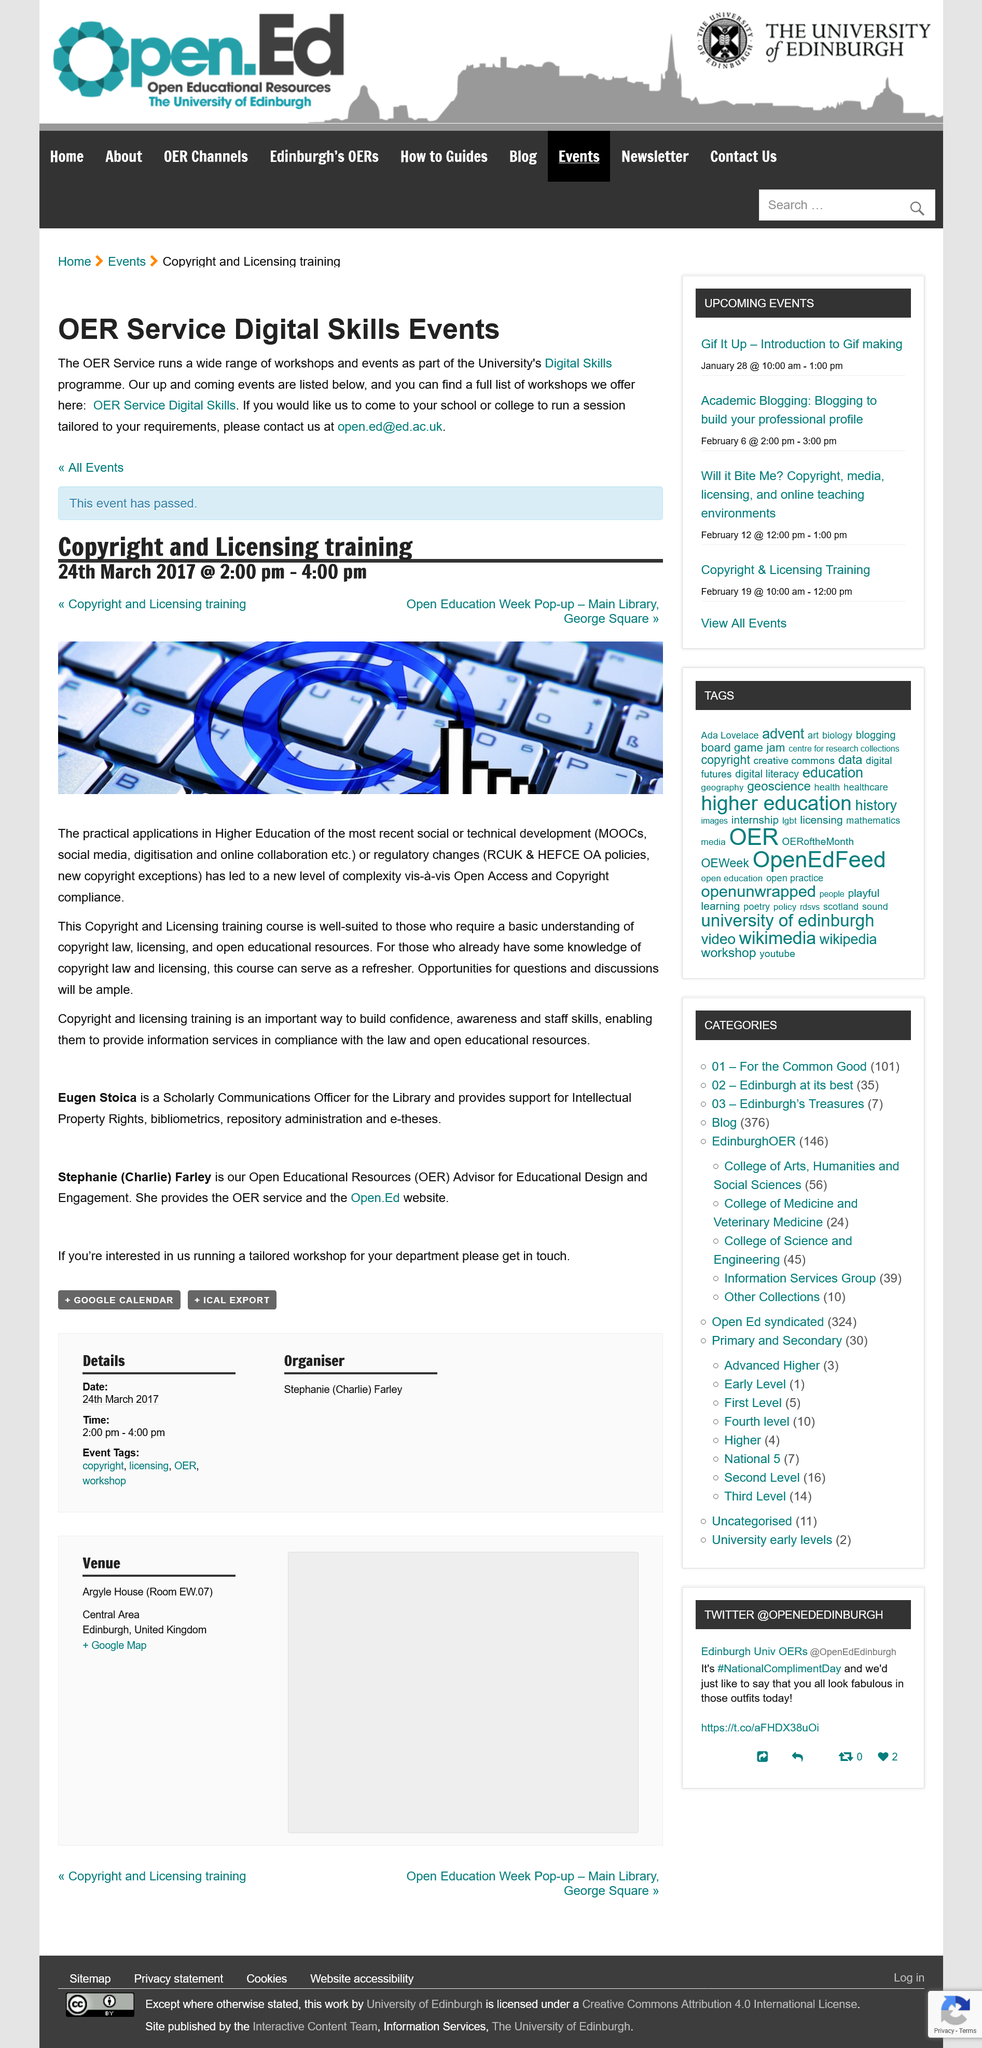Point out several critical features in this image. To arrange a digital skills event, please contact the Open Education team at [open.ed@ed.ac.uk](mailto:open.ed@ed.ac.uk). The most recent OER Service Digital Skill Event took place on March 24, 2017. The Open Education Week Pop-up will take place at the Main Library at George Square. 